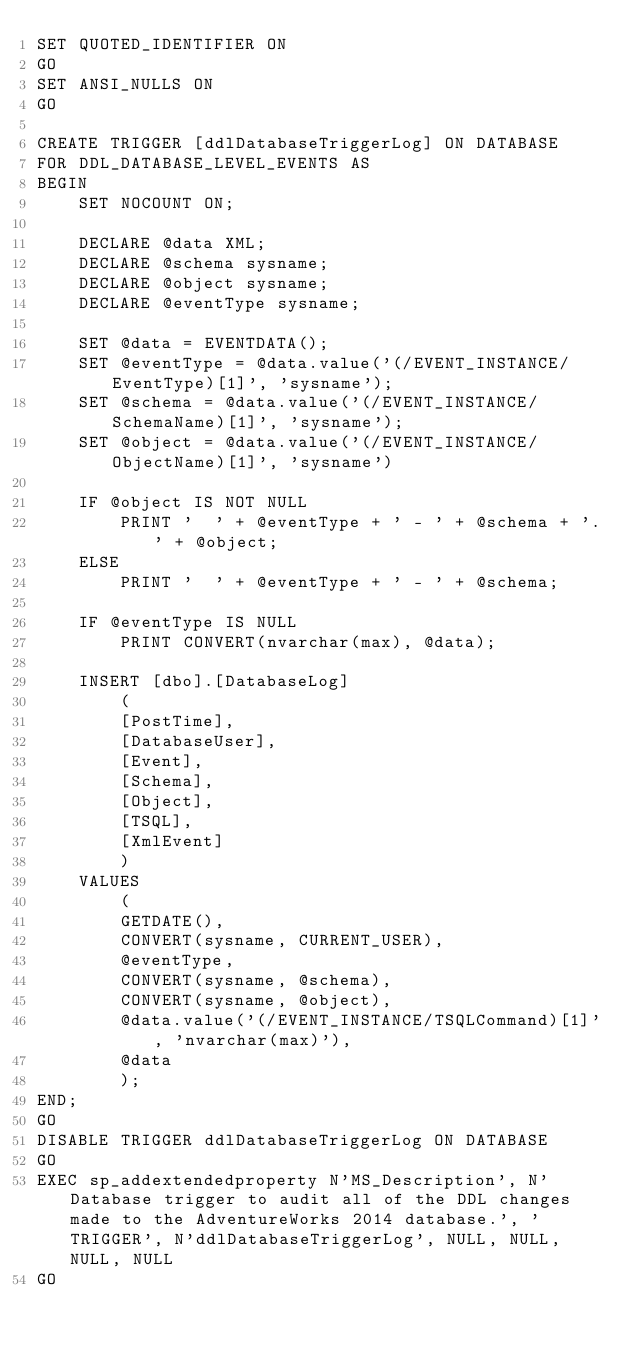<code> <loc_0><loc_0><loc_500><loc_500><_SQL_>SET QUOTED_IDENTIFIER ON
GO
SET ANSI_NULLS ON
GO

CREATE TRIGGER [ddlDatabaseTriggerLog] ON DATABASE 
FOR DDL_DATABASE_LEVEL_EVENTS AS 
BEGIN
    SET NOCOUNT ON;

    DECLARE @data XML;
    DECLARE @schema sysname;
    DECLARE @object sysname;
    DECLARE @eventType sysname;

    SET @data = EVENTDATA();
    SET @eventType = @data.value('(/EVENT_INSTANCE/EventType)[1]', 'sysname');
    SET @schema = @data.value('(/EVENT_INSTANCE/SchemaName)[1]', 'sysname');
    SET @object = @data.value('(/EVENT_INSTANCE/ObjectName)[1]', 'sysname') 

    IF @object IS NOT NULL
        PRINT '  ' + @eventType + ' - ' + @schema + '.' + @object;
    ELSE
        PRINT '  ' + @eventType + ' - ' + @schema;

    IF @eventType IS NULL
        PRINT CONVERT(nvarchar(max), @data);

    INSERT [dbo].[DatabaseLog] 
        (
        [PostTime], 
        [DatabaseUser], 
        [Event], 
        [Schema], 
        [Object], 
        [TSQL], 
        [XmlEvent]
        ) 
    VALUES 
        (
        GETDATE(), 
        CONVERT(sysname, CURRENT_USER), 
        @eventType, 
        CONVERT(sysname, @schema), 
        CONVERT(sysname, @object), 
        @data.value('(/EVENT_INSTANCE/TSQLCommand)[1]', 'nvarchar(max)'), 
        @data
        );
END;
GO
DISABLE TRIGGER ddlDatabaseTriggerLog ON DATABASE
GO
EXEC sp_addextendedproperty N'MS_Description', N'Database trigger to audit all of the DDL changes made to the AdventureWorks 2014 database.', 'TRIGGER', N'ddlDatabaseTriggerLog', NULL, NULL, NULL, NULL
GO
</code> 